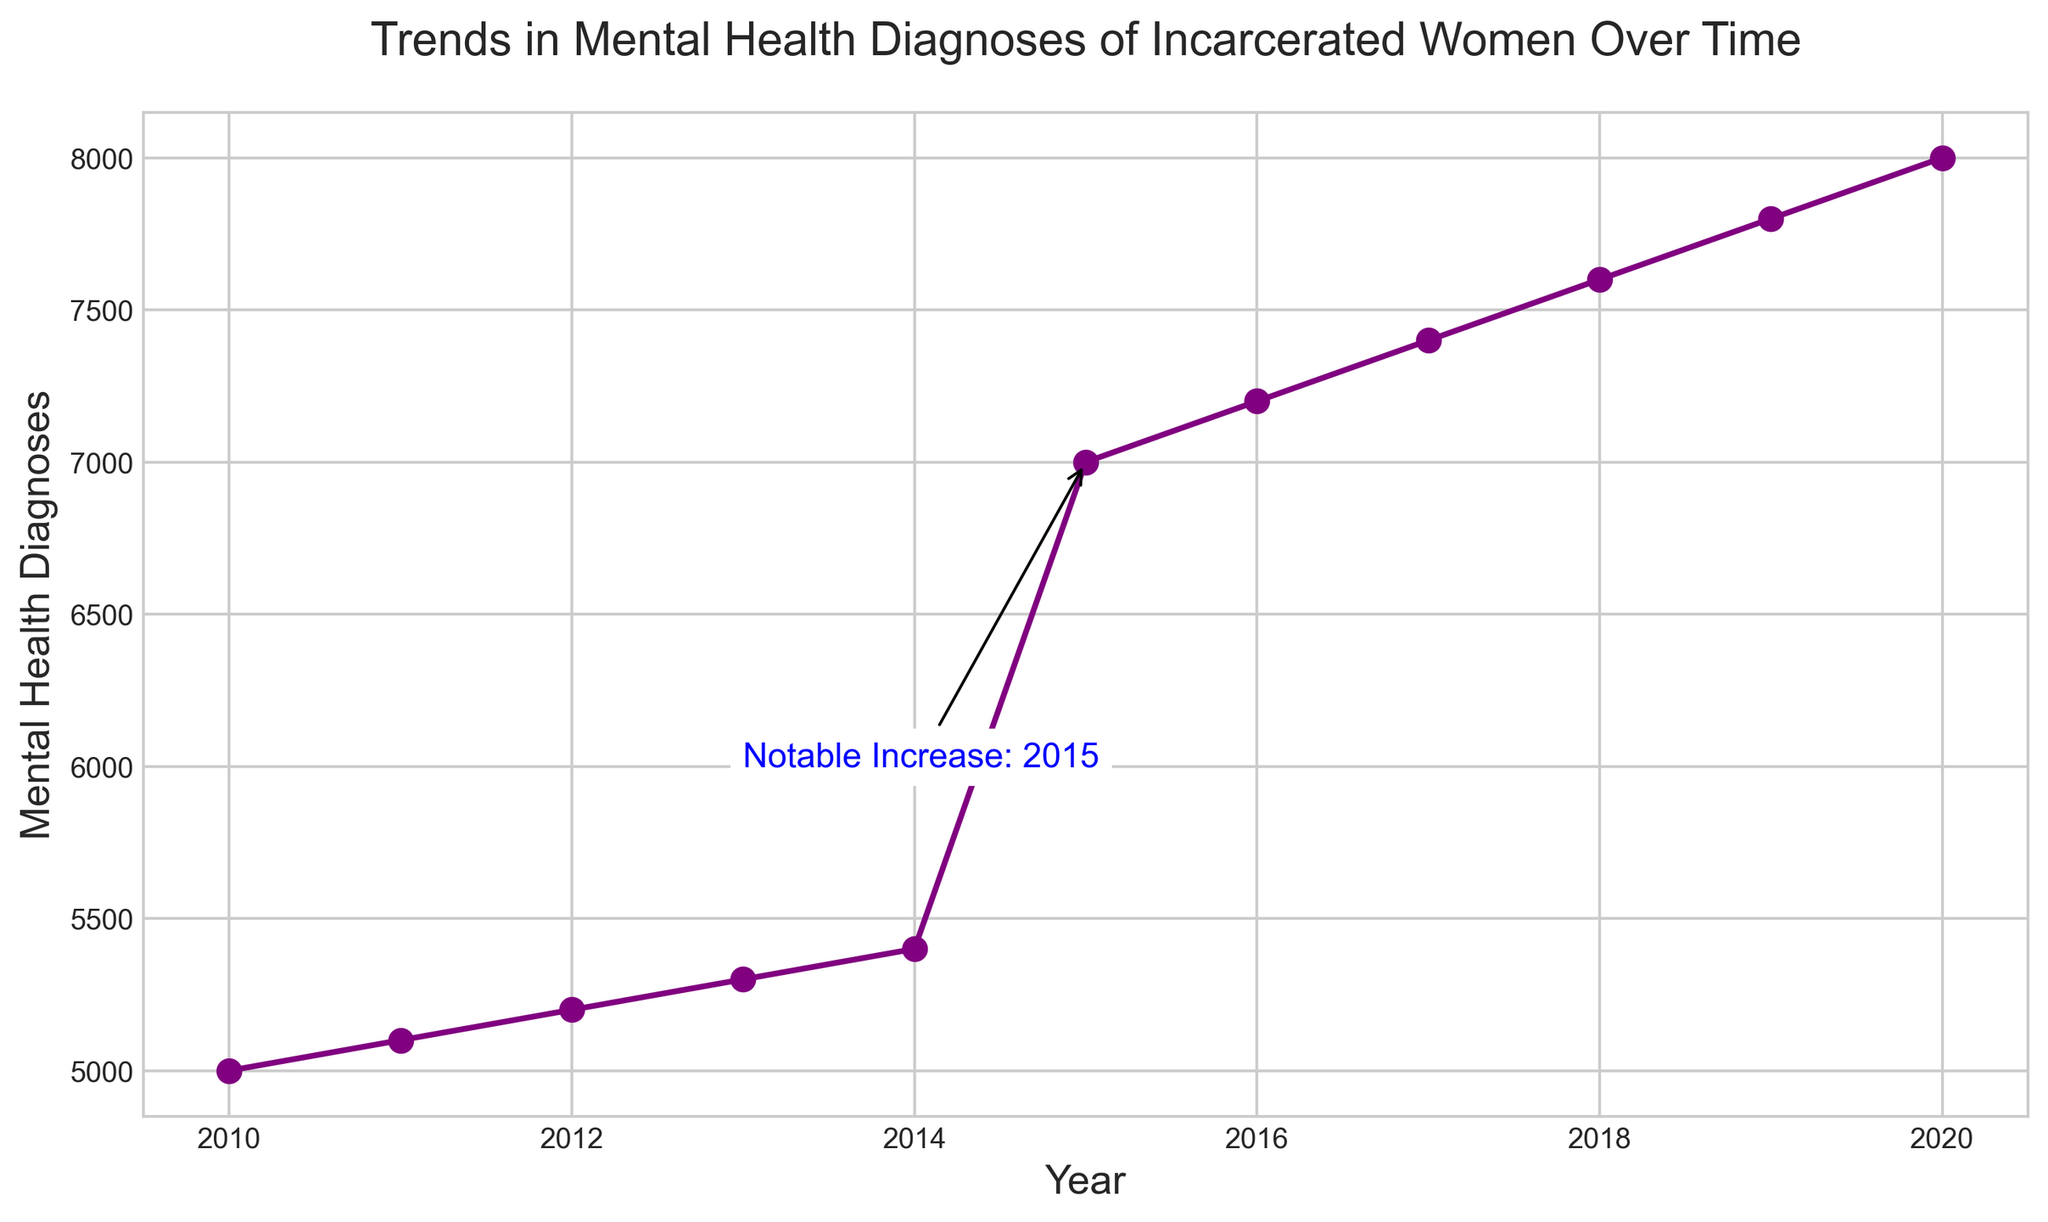What year saw the most significant increase in mental health diagnoses for incarcerated women? Based on the annotation in the figure, the year 2015 is highlighted as having a notable increase. This can be seen as the year with both the highest single increase in diagnoses and the annotation pointing it out.
Answer: 2015 How many more mental health diagnoses were there in 2015 compared to 2014? The number of diagnoses in 2015 is 7000, and in 2014 is 5400. Subtract 5400 from 7000 to find the increase.
Answer: 1600 What is the overall trend in mental health diagnoses of incarcerated women from 2010 to 2020? The line chart shows a steady increase from 2010 to 2020, with a notably sharp increase in 2015. This indicates a general upward trend in diagnoses over the time period.
Answer: Steady increase Which year had the fewest mental health diagnoses? The figure starts in 2010, with the lowest point on the chart being 2010 when the number of diagnoses was 5000.
Answer: 2010 What is the difference in mental health diagnoses between 2010 and 2020? In 2010, there were 5000 diagnoses, and in 2020, there were 8000. Subtract 5000 from 8000 to find the difference.
Answer: 3000 How does the rate of increase from 2019 to 2020 compare to the rate of increase from 2014 to 2015? From 2019 to 2020, the increase is 8000 - 7800 = 200 diagnoses. From 2014 to 2015, the increase is 7000 - 5400 = 1600 diagnoses. Thus, the increase from 2014 to 2015 is much larger.
Answer: 2014 to 2015 is much larger Between which two consecutive years was the smallest increase in mental health diagnoses observed? By comparing the differences between every pair of consecutive years, the smallest increase is from 2010 to 2011, where the increase is 5100 - 5000 = 100.
Answer: 2010 to 2011 What color is used to denote the line representing mental health diagnoses over time? Based on the description, the line color for mental health diagnoses is specified as purple.
Answer: Purple What is the average number of mental health diagnoses per year from 2010 to 2020? Add all values from 2010 to 2020: 5000 + 5100 + 5200 + 5300 + 5400 + 7000 + 7200 + 7400 + 7600 + 7800 + 8000 = 71000. Then divide by the number of years (11): 71000 / 11 = 6454.5
Answer: 6454.5 